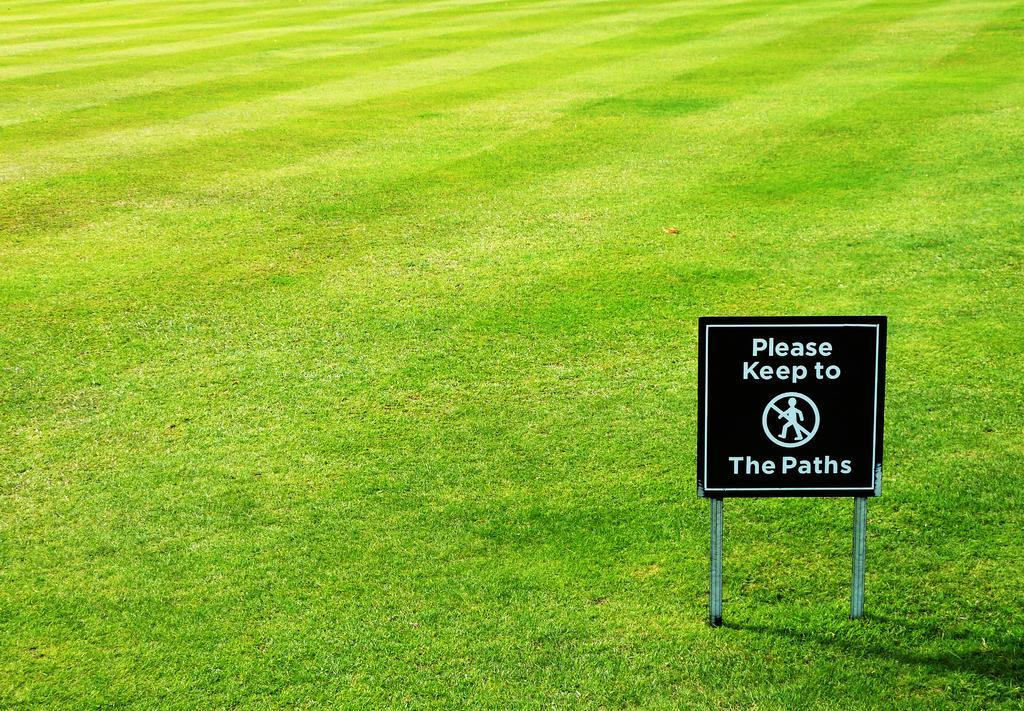Can you describe this image briefly? In this picture there is a sign board on the right side of the image, on the grassland and there is grassland around the area of the image. 